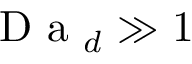<formula> <loc_0><loc_0><loc_500><loc_500>D a _ { d } \gg 1</formula> 